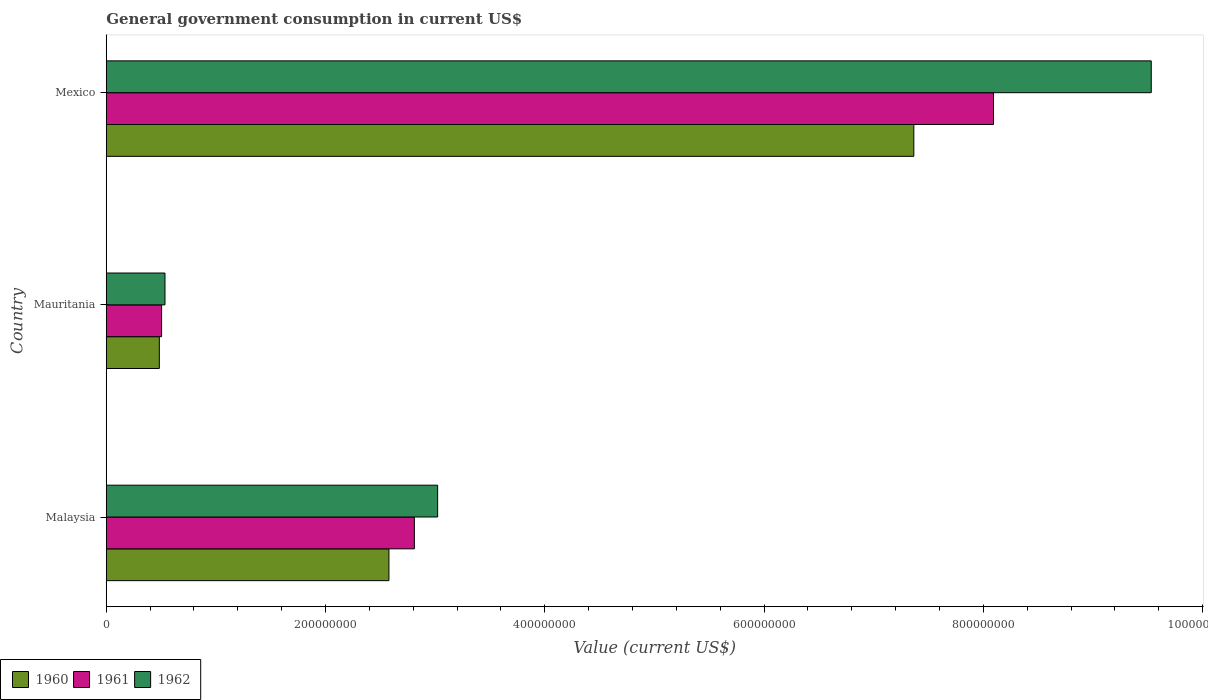How many different coloured bars are there?
Make the answer very short. 3. What is the label of the 1st group of bars from the top?
Offer a very short reply. Mexico. In how many cases, is the number of bars for a given country not equal to the number of legend labels?
Give a very brief answer. 0. What is the government conusmption in 1960 in Mexico?
Make the answer very short. 7.37e+08. Across all countries, what is the maximum government conusmption in 1961?
Offer a very short reply. 8.09e+08. Across all countries, what is the minimum government conusmption in 1961?
Offer a very short reply. 5.05e+07. In which country was the government conusmption in 1960 maximum?
Make the answer very short. Mexico. In which country was the government conusmption in 1960 minimum?
Provide a succinct answer. Mauritania. What is the total government conusmption in 1962 in the graph?
Your answer should be very brief. 1.31e+09. What is the difference between the government conusmption in 1962 in Malaysia and that in Mexico?
Make the answer very short. -6.51e+08. What is the difference between the government conusmption in 1962 in Malaysia and the government conusmption in 1961 in Mexico?
Your answer should be compact. -5.07e+08. What is the average government conusmption in 1961 per country?
Offer a terse response. 3.80e+08. What is the difference between the government conusmption in 1960 and government conusmption in 1962 in Mauritania?
Your response must be concise. -5.15e+06. What is the ratio of the government conusmption in 1962 in Mauritania to that in Mexico?
Keep it short and to the point. 0.06. Is the government conusmption in 1962 in Malaysia less than that in Mexico?
Your answer should be very brief. Yes. Is the difference between the government conusmption in 1960 in Mauritania and Mexico greater than the difference between the government conusmption in 1962 in Mauritania and Mexico?
Offer a terse response. Yes. What is the difference between the highest and the second highest government conusmption in 1962?
Offer a terse response. 6.51e+08. What is the difference between the highest and the lowest government conusmption in 1960?
Give a very brief answer. 6.88e+08. In how many countries, is the government conusmption in 1960 greater than the average government conusmption in 1960 taken over all countries?
Your answer should be very brief. 1. What does the 1st bar from the top in Malaysia represents?
Offer a terse response. 1962. How many countries are there in the graph?
Your answer should be compact. 3. What is the difference between two consecutive major ticks on the X-axis?
Make the answer very short. 2.00e+08. Are the values on the major ticks of X-axis written in scientific E-notation?
Give a very brief answer. No. Does the graph contain any zero values?
Your response must be concise. No. Does the graph contain grids?
Ensure brevity in your answer.  No. Where does the legend appear in the graph?
Offer a very short reply. Bottom left. How are the legend labels stacked?
Your answer should be compact. Horizontal. What is the title of the graph?
Your response must be concise. General government consumption in current US$. Does "1979" appear as one of the legend labels in the graph?
Your answer should be very brief. No. What is the label or title of the X-axis?
Provide a short and direct response. Value (current US$). What is the label or title of the Y-axis?
Your response must be concise. Country. What is the Value (current US$) of 1960 in Malaysia?
Provide a succinct answer. 2.58e+08. What is the Value (current US$) of 1961 in Malaysia?
Make the answer very short. 2.81e+08. What is the Value (current US$) of 1962 in Malaysia?
Ensure brevity in your answer.  3.02e+08. What is the Value (current US$) in 1960 in Mauritania?
Offer a very short reply. 4.84e+07. What is the Value (current US$) in 1961 in Mauritania?
Your answer should be very brief. 5.05e+07. What is the Value (current US$) in 1962 in Mauritania?
Give a very brief answer. 5.36e+07. What is the Value (current US$) of 1960 in Mexico?
Offer a terse response. 7.37e+08. What is the Value (current US$) of 1961 in Mexico?
Offer a terse response. 8.09e+08. What is the Value (current US$) of 1962 in Mexico?
Your answer should be very brief. 9.53e+08. Across all countries, what is the maximum Value (current US$) in 1960?
Make the answer very short. 7.37e+08. Across all countries, what is the maximum Value (current US$) in 1961?
Offer a terse response. 8.09e+08. Across all countries, what is the maximum Value (current US$) in 1962?
Provide a short and direct response. 9.53e+08. Across all countries, what is the minimum Value (current US$) of 1960?
Provide a short and direct response. 4.84e+07. Across all countries, what is the minimum Value (current US$) in 1961?
Offer a very short reply. 5.05e+07. Across all countries, what is the minimum Value (current US$) in 1962?
Keep it short and to the point. 5.36e+07. What is the total Value (current US$) of 1960 in the graph?
Offer a very short reply. 1.04e+09. What is the total Value (current US$) of 1961 in the graph?
Ensure brevity in your answer.  1.14e+09. What is the total Value (current US$) in 1962 in the graph?
Offer a terse response. 1.31e+09. What is the difference between the Value (current US$) in 1960 in Malaysia and that in Mauritania?
Ensure brevity in your answer.  2.09e+08. What is the difference between the Value (current US$) in 1961 in Malaysia and that in Mauritania?
Give a very brief answer. 2.31e+08. What is the difference between the Value (current US$) of 1962 in Malaysia and that in Mauritania?
Make the answer very short. 2.49e+08. What is the difference between the Value (current US$) of 1960 in Malaysia and that in Mexico?
Make the answer very short. -4.79e+08. What is the difference between the Value (current US$) in 1961 in Malaysia and that in Mexico?
Keep it short and to the point. -5.28e+08. What is the difference between the Value (current US$) of 1962 in Malaysia and that in Mexico?
Provide a short and direct response. -6.51e+08. What is the difference between the Value (current US$) in 1960 in Mauritania and that in Mexico?
Your answer should be compact. -6.88e+08. What is the difference between the Value (current US$) in 1961 in Mauritania and that in Mexico?
Offer a terse response. -7.59e+08. What is the difference between the Value (current US$) of 1962 in Mauritania and that in Mexico?
Your answer should be very brief. -9.00e+08. What is the difference between the Value (current US$) in 1960 in Malaysia and the Value (current US$) in 1961 in Mauritania?
Your response must be concise. 2.07e+08. What is the difference between the Value (current US$) of 1960 in Malaysia and the Value (current US$) of 1962 in Mauritania?
Your response must be concise. 2.04e+08. What is the difference between the Value (current US$) in 1961 in Malaysia and the Value (current US$) in 1962 in Mauritania?
Provide a short and direct response. 2.27e+08. What is the difference between the Value (current US$) in 1960 in Malaysia and the Value (current US$) in 1961 in Mexico?
Give a very brief answer. -5.51e+08. What is the difference between the Value (current US$) in 1960 in Malaysia and the Value (current US$) in 1962 in Mexico?
Your answer should be very brief. -6.95e+08. What is the difference between the Value (current US$) in 1961 in Malaysia and the Value (current US$) in 1962 in Mexico?
Your response must be concise. -6.72e+08. What is the difference between the Value (current US$) of 1960 in Mauritania and the Value (current US$) of 1961 in Mexico?
Offer a terse response. -7.61e+08. What is the difference between the Value (current US$) in 1960 in Mauritania and the Value (current US$) in 1962 in Mexico?
Give a very brief answer. -9.05e+08. What is the difference between the Value (current US$) of 1961 in Mauritania and the Value (current US$) of 1962 in Mexico?
Make the answer very short. -9.03e+08. What is the average Value (current US$) in 1960 per country?
Offer a very short reply. 3.48e+08. What is the average Value (current US$) of 1961 per country?
Ensure brevity in your answer.  3.80e+08. What is the average Value (current US$) in 1962 per country?
Provide a short and direct response. 4.36e+08. What is the difference between the Value (current US$) of 1960 and Value (current US$) of 1961 in Malaysia?
Your response must be concise. -2.32e+07. What is the difference between the Value (current US$) of 1960 and Value (current US$) of 1962 in Malaysia?
Ensure brevity in your answer.  -4.44e+07. What is the difference between the Value (current US$) in 1961 and Value (current US$) in 1962 in Malaysia?
Provide a short and direct response. -2.12e+07. What is the difference between the Value (current US$) in 1960 and Value (current US$) in 1961 in Mauritania?
Provide a short and direct response. -2.06e+06. What is the difference between the Value (current US$) in 1960 and Value (current US$) in 1962 in Mauritania?
Provide a succinct answer. -5.15e+06. What is the difference between the Value (current US$) in 1961 and Value (current US$) in 1962 in Mauritania?
Offer a very short reply. -3.09e+06. What is the difference between the Value (current US$) of 1960 and Value (current US$) of 1961 in Mexico?
Keep it short and to the point. -7.27e+07. What is the difference between the Value (current US$) of 1960 and Value (current US$) of 1962 in Mexico?
Give a very brief answer. -2.17e+08. What is the difference between the Value (current US$) in 1961 and Value (current US$) in 1962 in Mexico?
Ensure brevity in your answer.  -1.44e+08. What is the ratio of the Value (current US$) of 1960 in Malaysia to that in Mauritania?
Ensure brevity in your answer.  5.33. What is the ratio of the Value (current US$) in 1961 in Malaysia to that in Mauritania?
Your answer should be compact. 5.57. What is the ratio of the Value (current US$) in 1962 in Malaysia to that in Mauritania?
Your answer should be compact. 5.64. What is the ratio of the Value (current US$) in 1960 in Malaysia to that in Mexico?
Keep it short and to the point. 0.35. What is the ratio of the Value (current US$) of 1961 in Malaysia to that in Mexico?
Ensure brevity in your answer.  0.35. What is the ratio of the Value (current US$) of 1962 in Malaysia to that in Mexico?
Your answer should be very brief. 0.32. What is the ratio of the Value (current US$) in 1960 in Mauritania to that in Mexico?
Your answer should be very brief. 0.07. What is the ratio of the Value (current US$) of 1961 in Mauritania to that in Mexico?
Ensure brevity in your answer.  0.06. What is the ratio of the Value (current US$) in 1962 in Mauritania to that in Mexico?
Provide a short and direct response. 0.06. What is the difference between the highest and the second highest Value (current US$) in 1960?
Keep it short and to the point. 4.79e+08. What is the difference between the highest and the second highest Value (current US$) of 1961?
Offer a very short reply. 5.28e+08. What is the difference between the highest and the second highest Value (current US$) in 1962?
Provide a short and direct response. 6.51e+08. What is the difference between the highest and the lowest Value (current US$) in 1960?
Ensure brevity in your answer.  6.88e+08. What is the difference between the highest and the lowest Value (current US$) in 1961?
Your response must be concise. 7.59e+08. What is the difference between the highest and the lowest Value (current US$) in 1962?
Offer a very short reply. 9.00e+08. 